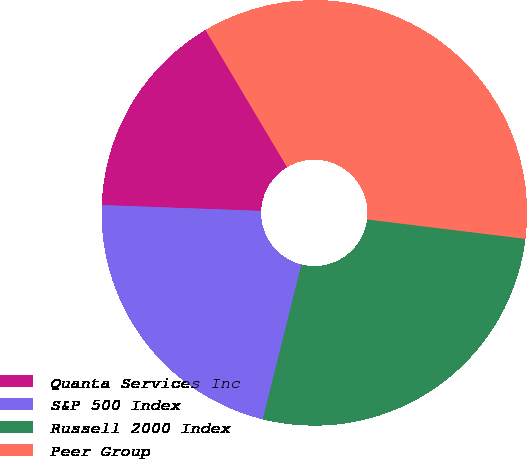Convert chart to OTSL. <chart><loc_0><loc_0><loc_500><loc_500><pie_chart><fcel>Quanta Services Inc<fcel>S&P 500 Index<fcel>Russell 2000 Index<fcel>Peer Group<nl><fcel>15.88%<fcel>21.69%<fcel>26.95%<fcel>35.48%<nl></chart> 